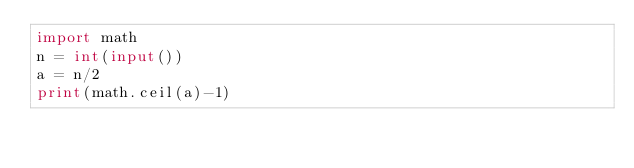Convert code to text. <code><loc_0><loc_0><loc_500><loc_500><_Python_>import math
n = int(input())
a = n/2
print(math.ceil(a)-1)</code> 